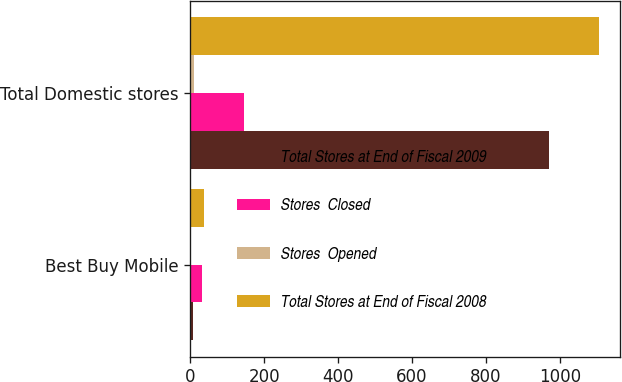Convert chart. <chart><loc_0><loc_0><loc_500><loc_500><stacked_bar_chart><ecel><fcel>Best Buy Mobile<fcel>Total Domestic stores<nl><fcel>Total Stores at End of Fiscal 2009<fcel>9<fcel>971<nl><fcel>Stores  Closed<fcel>32<fcel>147<nl><fcel>Stores  Opened<fcel>3<fcel>11<nl><fcel>Total Stores at End of Fiscal 2008<fcel>38<fcel>1107<nl></chart> 